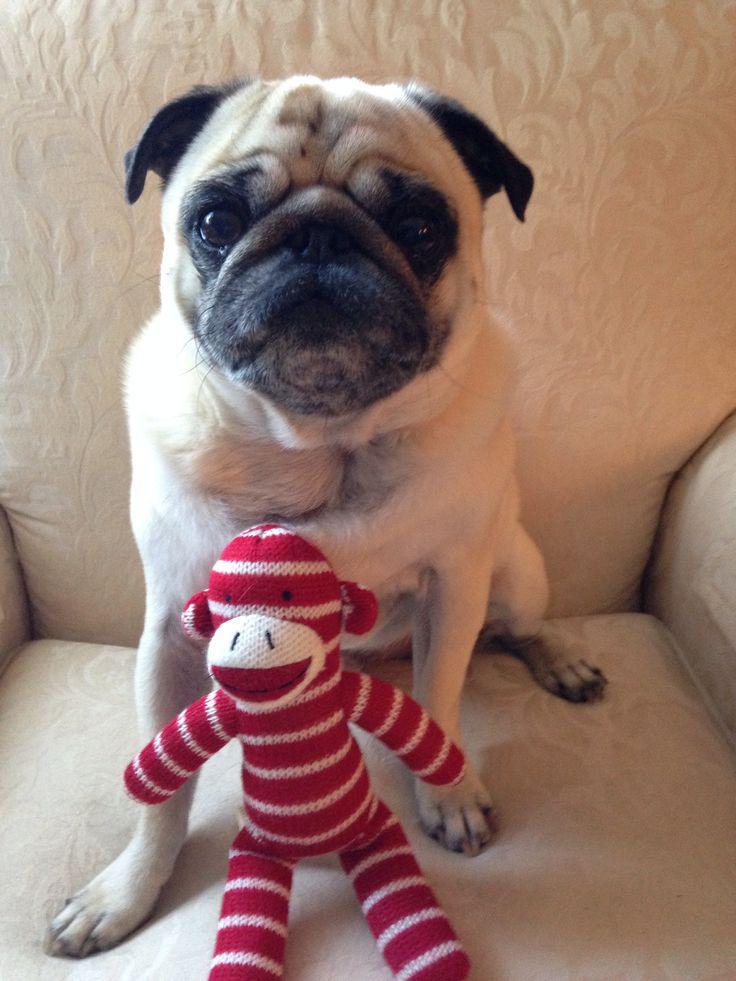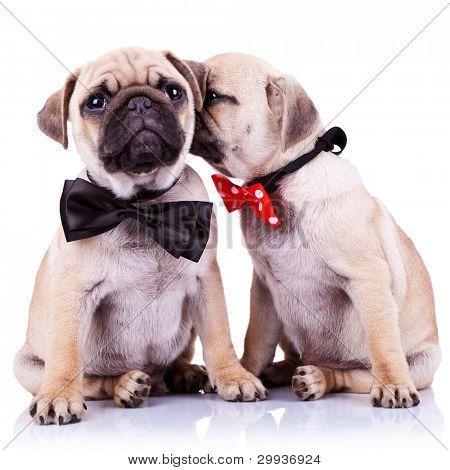The first image is the image on the left, the second image is the image on the right. Assess this claim about the two images: "Each image shows two buff-beige pugs with darker muzzles posed side-by-side facing forward.". Correct or not? Answer yes or no. No. The first image is the image on the left, the second image is the image on the right. Considering the images on both sides, is "two pugs are wearing costumes" valid? Answer yes or no. Yes. 